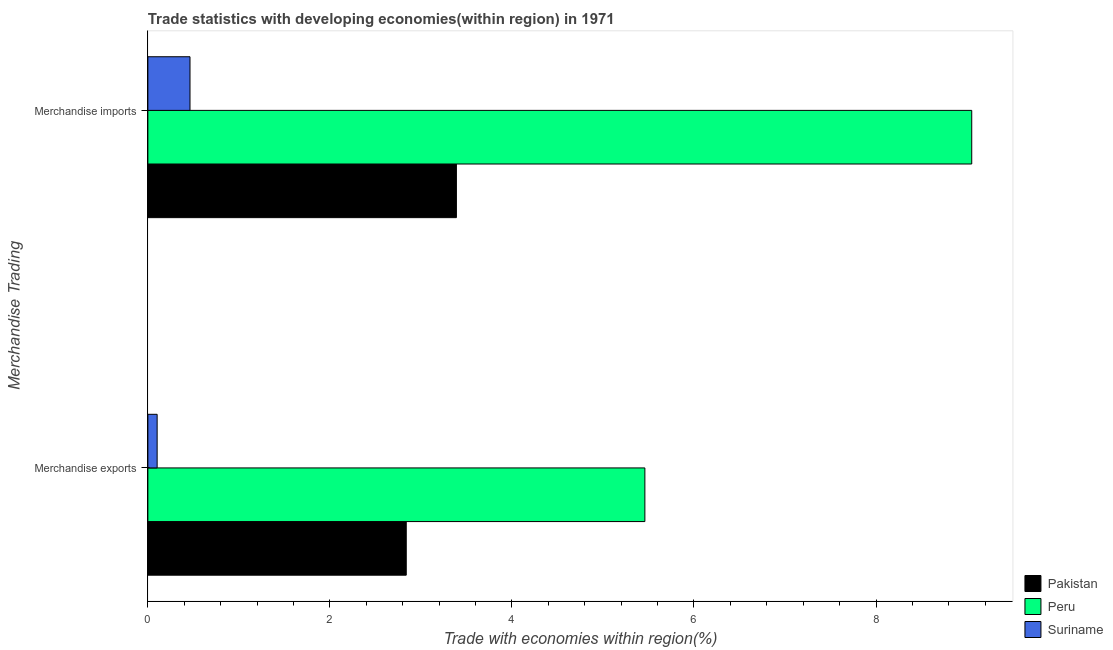How many groups of bars are there?
Provide a short and direct response. 2. How many bars are there on the 2nd tick from the bottom?
Ensure brevity in your answer.  3. What is the label of the 1st group of bars from the top?
Your response must be concise. Merchandise imports. What is the merchandise imports in Peru?
Make the answer very short. 9.05. Across all countries, what is the maximum merchandise imports?
Offer a very short reply. 9.05. Across all countries, what is the minimum merchandise imports?
Give a very brief answer. 0.46. In which country was the merchandise imports minimum?
Give a very brief answer. Suriname. What is the total merchandise imports in the graph?
Make the answer very short. 12.9. What is the difference between the merchandise imports in Peru and that in Pakistan?
Keep it short and to the point. 5.66. What is the difference between the merchandise exports in Peru and the merchandise imports in Suriname?
Your answer should be compact. 5. What is the average merchandise imports per country?
Make the answer very short. 4.3. What is the difference between the merchandise exports and merchandise imports in Peru?
Ensure brevity in your answer.  -3.59. In how many countries, is the merchandise exports greater than 2.8 %?
Your answer should be compact. 2. What is the ratio of the merchandise exports in Peru to that in Pakistan?
Your response must be concise. 1.92. In how many countries, is the merchandise exports greater than the average merchandise exports taken over all countries?
Provide a short and direct response. 2. What does the 3rd bar from the top in Merchandise imports represents?
Provide a succinct answer. Pakistan. How many countries are there in the graph?
Offer a very short reply. 3. Does the graph contain any zero values?
Provide a short and direct response. No. Where does the legend appear in the graph?
Ensure brevity in your answer.  Bottom right. How many legend labels are there?
Provide a succinct answer. 3. How are the legend labels stacked?
Your answer should be very brief. Vertical. What is the title of the graph?
Keep it short and to the point. Trade statistics with developing economies(within region) in 1971. Does "High income" appear as one of the legend labels in the graph?
Ensure brevity in your answer.  No. What is the label or title of the X-axis?
Your answer should be very brief. Trade with economies within region(%). What is the label or title of the Y-axis?
Ensure brevity in your answer.  Merchandise Trading. What is the Trade with economies within region(%) of Pakistan in Merchandise exports?
Ensure brevity in your answer.  2.84. What is the Trade with economies within region(%) of Peru in Merchandise exports?
Provide a short and direct response. 5.46. What is the Trade with economies within region(%) of Suriname in Merchandise exports?
Keep it short and to the point. 0.1. What is the Trade with economies within region(%) of Pakistan in Merchandise imports?
Ensure brevity in your answer.  3.39. What is the Trade with economies within region(%) in Peru in Merchandise imports?
Keep it short and to the point. 9.05. What is the Trade with economies within region(%) in Suriname in Merchandise imports?
Provide a short and direct response. 0.46. Across all Merchandise Trading, what is the maximum Trade with economies within region(%) in Pakistan?
Give a very brief answer. 3.39. Across all Merchandise Trading, what is the maximum Trade with economies within region(%) of Peru?
Provide a succinct answer. 9.05. Across all Merchandise Trading, what is the maximum Trade with economies within region(%) of Suriname?
Make the answer very short. 0.46. Across all Merchandise Trading, what is the minimum Trade with economies within region(%) of Pakistan?
Make the answer very short. 2.84. Across all Merchandise Trading, what is the minimum Trade with economies within region(%) of Peru?
Your response must be concise. 5.46. Across all Merchandise Trading, what is the minimum Trade with economies within region(%) in Suriname?
Offer a very short reply. 0.1. What is the total Trade with economies within region(%) of Pakistan in the graph?
Provide a succinct answer. 6.23. What is the total Trade with economies within region(%) of Peru in the graph?
Keep it short and to the point. 14.51. What is the total Trade with economies within region(%) of Suriname in the graph?
Provide a succinct answer. 0.56. What is the difference between the Trade with economies within region(%) of Pakistan in Merchandise exports and that in Merchandise imports?
Make the answer very short. -0.55. What is the difference between the Trade with economies within region(%) of Peru in Merchandise exports and that in Merchandise imports?
Offer a terse response. -3.59. What is the difference between the Trade with economies within region(%) in Suriname in Merchandise exports and that in Merchandise imports?
Provide a succinct answer. -0.36. What is the difference between the Trade with economies within region(%) in Pakistan in Merchandise exports and the Trade with economies within region(%) in Peru in Merchandise imports?
Offer a terse response. -6.21. What is the difference between the Trade with economies within region(%) of Pakistan in Merchandise exports and the Trade with economies within region(%) of Suriname in Merchandise imports?
Make the answer very short. 2.38. What is the difference between the Trade with economies within region(%) of Peru in Merchandise exports and the Trade with economies within region(%) of Suriname in Merchandise imports?
Your answer should be very brief. 5. What is the average Trade with economies within region(%) in Pakistan per Merchandise Trading?
Ensure brevity in your answer.  3.11. What is the average Trade with economies within region(%) in Peru per Merchandise Trading?
Make the answer very short. 7.26. What is the average Trade with economies within region(%) in Suriname per Merchandise Trading?
Provide a short and direct response. 0.28. What is the difference between the Trade with economies within region(%) of Pakistan and Trade with economies within region(%) of Peru in Merchandise exports?
Your response must be concise. -2.62. What is the difference between the Trade with economies within region(%) of Pakistan and Trade with economies within region(%) of Suriname in Merchandise exports?
Make the answer very short. 2.74. What is the difference between the Trade with economies within region(%) of Peru and Trade with economies within region(%) of Suriname in Merchandise exports?
Offer a terse response. 5.36. What is the difference between the Trade with economies within region(%) of Pakistan and Trade with economies within region(%) of Peru in Merchandise imports?
Offer a terse response. -5.66. What is the difference between the Trade with economies within region(%) of Pakistan and Trade with economies within region(%) of Suriname in Merchandise imports?
Provide a short and direct response. 2.93. What is the difference between the Trade with economies within region(%) in Peru and Trade with economies within region(%) in Suriname in Merchandise imports?
Make the answer very short. 8.59. What is the ratio of the Trade with economies within region(%) of Pakistan in Merchandise exports to that in Merchandise imports?
Ensure brevity in your answer.  0.84. What is the ratio of the Trade with economies within region(%) of Peru in Merchandise exports to that in Merchandise imports?
Give a very brief answer. 0.6. What is the ratio of the Trade with economies within region(%) of Suriname in Merchandise exports to that in Merchandise imports?
Your answer should be compact. 0.22. What is the difference between the highest and the second highest Trade with economies within region(%) in Pakistan?
Provide a succinct answer. 0.55. What is the difference between the highest and the second highest Trade with economies within region(%) of Peru?
Offer a terse response. 3.59. What is the difference between the highest and the second highest Trade with economies within region(%) in Suriname?
Provide a short and direct response. 0.36. What is the difference between the highest and the lowest Trade with economies within region(%) in Pakistan?
Give a very brief answer. 0.55. What is the difference between the highest and the lowest Trade with economies within region(%) in Peru?
Your answer should be very brief. 3.59. What is the difference between the highest and the lowest Trade with economies within region(%) of Suriname?
Make the answer very short. 0.36. 